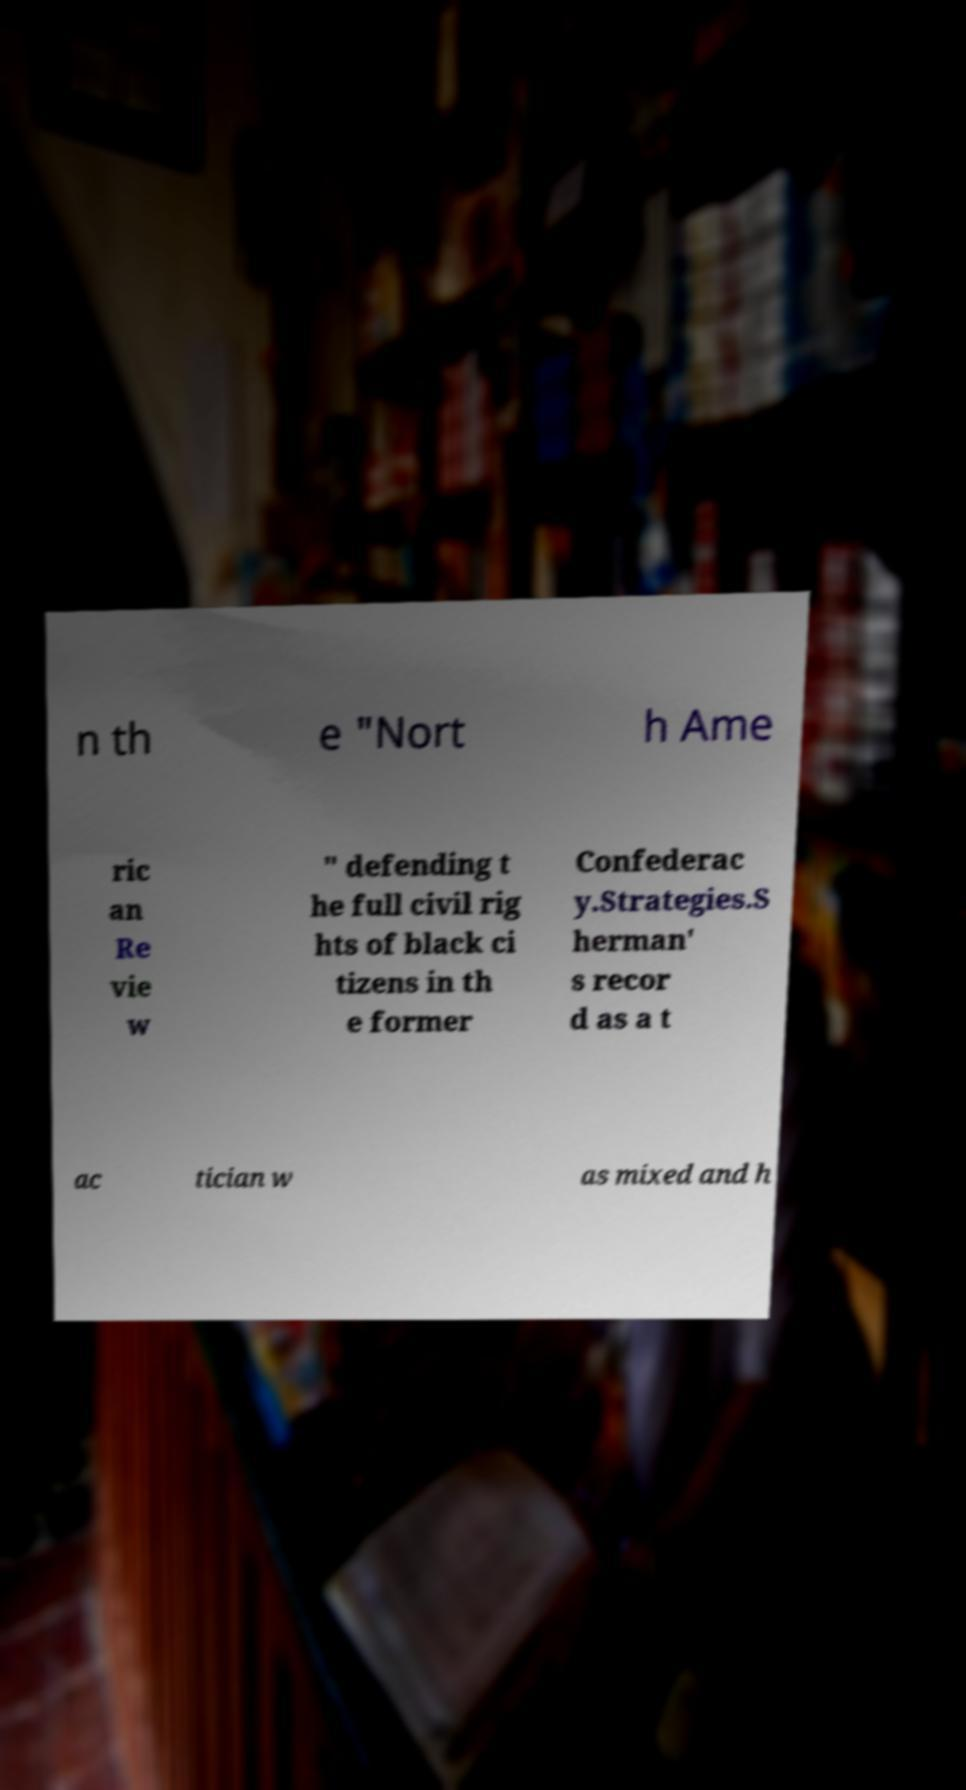Could you assist in decoding the text presented in this image and type it out clearly? n th e "Nort h Ame ric an Re vie w " defending t he full civil rig hts of black ci tizens in th e former Confederac y.Strategies.S herman' s recor d as a t ac tician w as mixed and h 